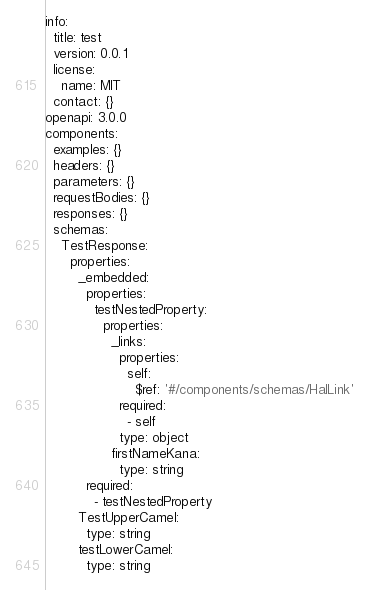Convert code to text. <code><loc_0><loc_0><loc_500><loc_500><_YAML_>info:
  title: test
  version: 0.0.1
  license:
    name: MIT
  contact: {}
openapi: 3.0.0
components:
  examples: {}
  headers: {}
  parameters: {}
  requestBodies: {}
  responses: {}
  schemas:
    TestResponse:
      properties:
        _embedded:
          properties:
            testNestedProperty:
              properties:
                _links:
                  properties:
                    self:
                      $ref: '#/components/schemas/HalLink'
                  required:
                    - self
                  type: object
                firstNameKana:
                  type: string
          required:
            - testNestedProperty
        TestUpperCamel:
          type: string
        testLowerCamel:
          type: string
</code> 